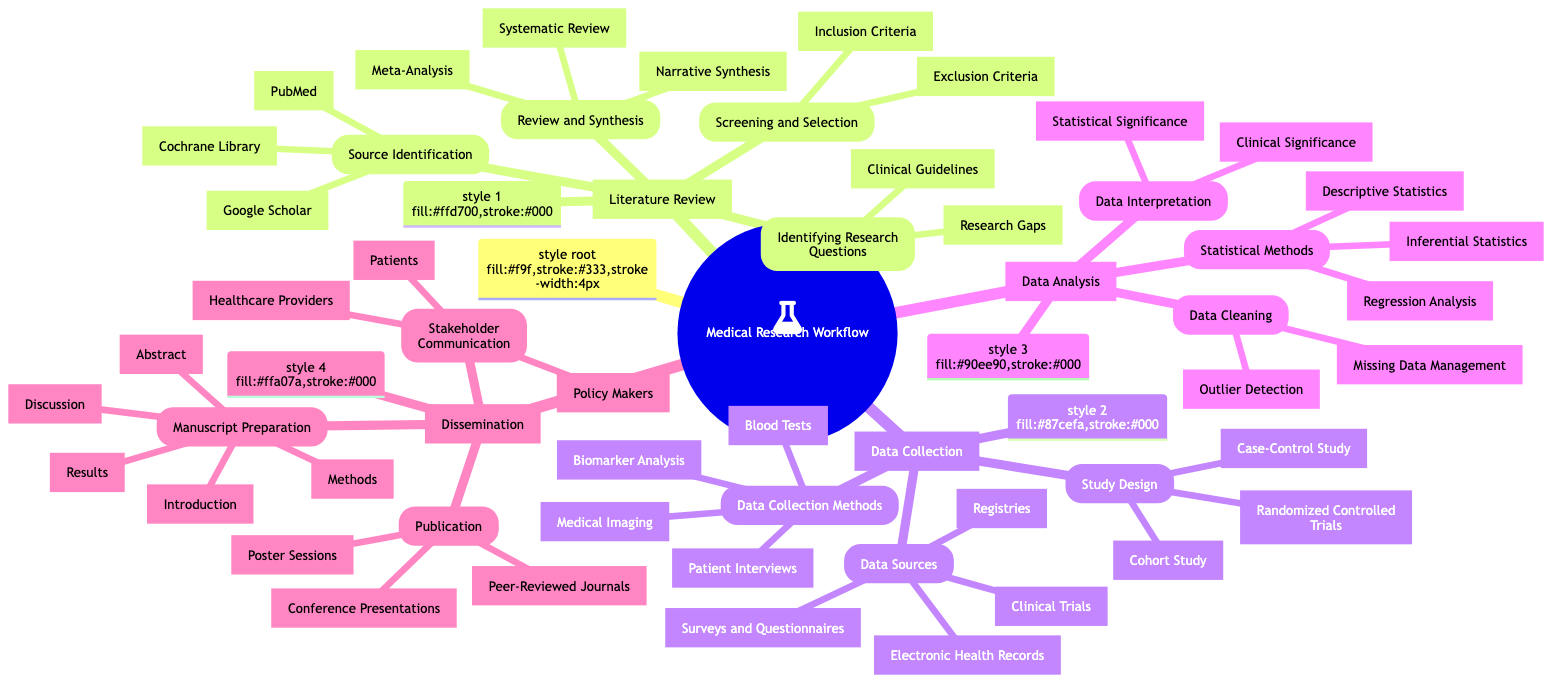What are the main sections of the Medical Research Workflow? The diagram has four main sections: Literature Review, Data Collection, Data Analysis, and Dissemination. Each section is clearly labeled and distinct.
Answer: Literature Review, Data Collection, Data Analysis, Dissemination How many methods are listed under Data Collection? In the Data Collection section, there are three listed methods: Study Design, Data Sources, and Data Collection Methods. Each category contains specific types. Counting these gives a total of three methods.
Answer: 3 What is one source identified in the Literature Review section? Under the Source Identification part of the Literature Review, PubMed is mentioned as one of the sources where research can be found. This is a specific node under the subsection.
Answer: PubMed Which statistical method is mentioned in the Data Analysis section? The diagram lists three statistical methods under the Data Analysis section: Descriptive Statistics, Inferential Statistics, and Regression Analysis. One of them, such as Descriptive Statistics, can be quoted as a response.
Answer: Descriptive Statistics In what section would you find information about Stakeholder Communication? Stakeholder Communication is found in the Dissemination section, which details the communication strategies with different stakeholders post-research. This can be easily located by examining the nodes listed under the Dissemination section.
Answer: Dissemination How many types of literature review synthesis methods are mentioned? The Review and Synthesis part of the Literature Review lists three methods: Systematic Review, Meta-Analysis, and Narrative Synthesis. These can be counted directly from their respective node.
Answer: 3 What is the first step in the Data Collection section? The first step in the Data Collection section is Study Design. This is the first node listed under the second main section, indicating the initial phase of data gathering.
Answer: Study Design What types of data sources are identified under Data Collection? Under Data Sources in the Data Collection section, Electronic Health Records, Surveys and Questionnaires, Clinical Trials, and Registries are listed. This captures the different types of sources that can be used for data.
Answer: Electronic Health Records, Surveys and Questionnaires, Clinical Trials, Registries How many components are listed in the Manuscript Preparation section? The Manuscript Preparation section includes five components: Abstract, Introduction, Methods, Results, and Discussion. Counting these components gives a total of five.
Answer: 5 What does the Review and Synthesis part help with? The Review and Synthesis part helps in evaluating and consolidating existing literature to inform future research, specifically through methods such as Systematic Review and Meta-Analysis listed under this section.
Answer: Evaluating and consolidating existing literature 